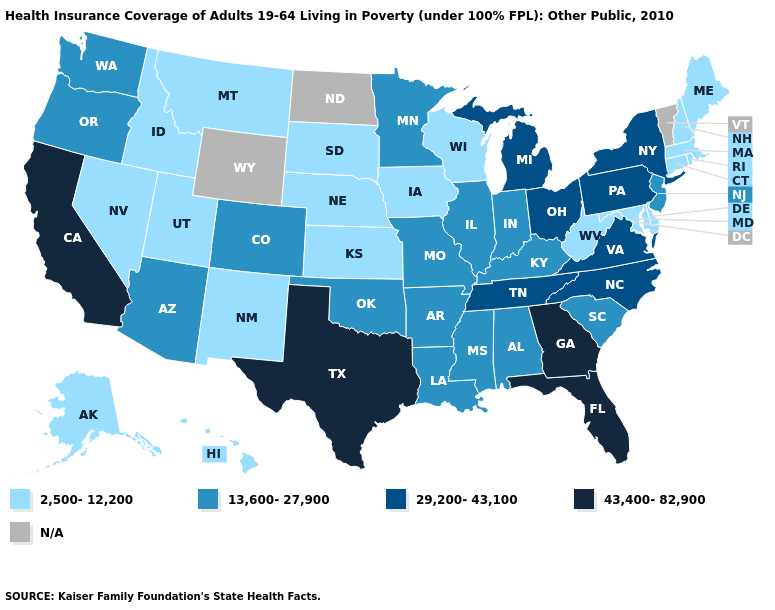What is the value of Alabama?
Short answer required. 13,600-27,900. What is the lowest value in the USA?
Quick response, please. 2,500-12,200. Which states have the lowest value in the Northeast?
Give a very brief answer. Connecticut, Maine, Massachusetts, New Hampshire, Rhode Island. Name the states that have a value in the range 2,500-12,200?
Quick response, please. Alaska, Connecticut, Delaware, Hawaii, Idaho, Iowa, Kansas, Maine, Maryland, Massachusetts, Montana, Nebraska, Nevada, New Hampshire, New Mexico, Rhode Island, South Dakota, Utah, West Virginia, Wisconsin. What is the value of South Carolina?
Quick response, please. 13,600-27,900. What is the lowest value in the West?
Write a very short answer. 2,500-12,200. What is the value of Wisconsin?
Concise answer only. 2,500-12,200. Name the states that have a value in the range N/A?
Give a very brief answer. North Dakota, Vermont, Wyoming. Is the legend a continuous bar?
Answer briefly. No. Name the states that have a value in the range 13,600-27,900?
Write a very short answer. Alabama, Arizona, Arkansas, Colorado, Illinois, Indiana, Kentucky, Louisiana, Minnesota, Mississippi, Missouri, New Jersey, Oklahoma, Oregon, South Carolina, Washington. Which states have the lowest value in the USA?
Write a very short answer. Alaska, Connecticut, Delaware, Hawaii, Idaho, Iowa, Kansas, Maine, Maryland, Massachusetts, Montana, Nebraska, Nevada, New Hampshire, New Mexico, Rhode Island, South Dakota, Utah, West Virginia, Wisconsin. Is the legend a continuous bar?
Write a very short answer. No. Which states have the lowest value in the Northeast?
Give a very brief answer. Connecticut, Maine, Massachusetts, New Hampshire, Rhode Island. Name the states that have a value in the range 2,500-12,200?
Short answer required. Alaska, Connecticut, Delaware, Hawaii, Idaho, Iowa, Kansas, Maine, Maryland, Massachusetts, Montana, Nebraska, Nevada, New Hampshire, New Mexico, Rhode Island, South Dakota, Utah, West Virginia, Wisconsin. 